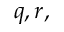<formula> <loc_0><loc_0><loc_500><loc_500>q , r ,</formula> 